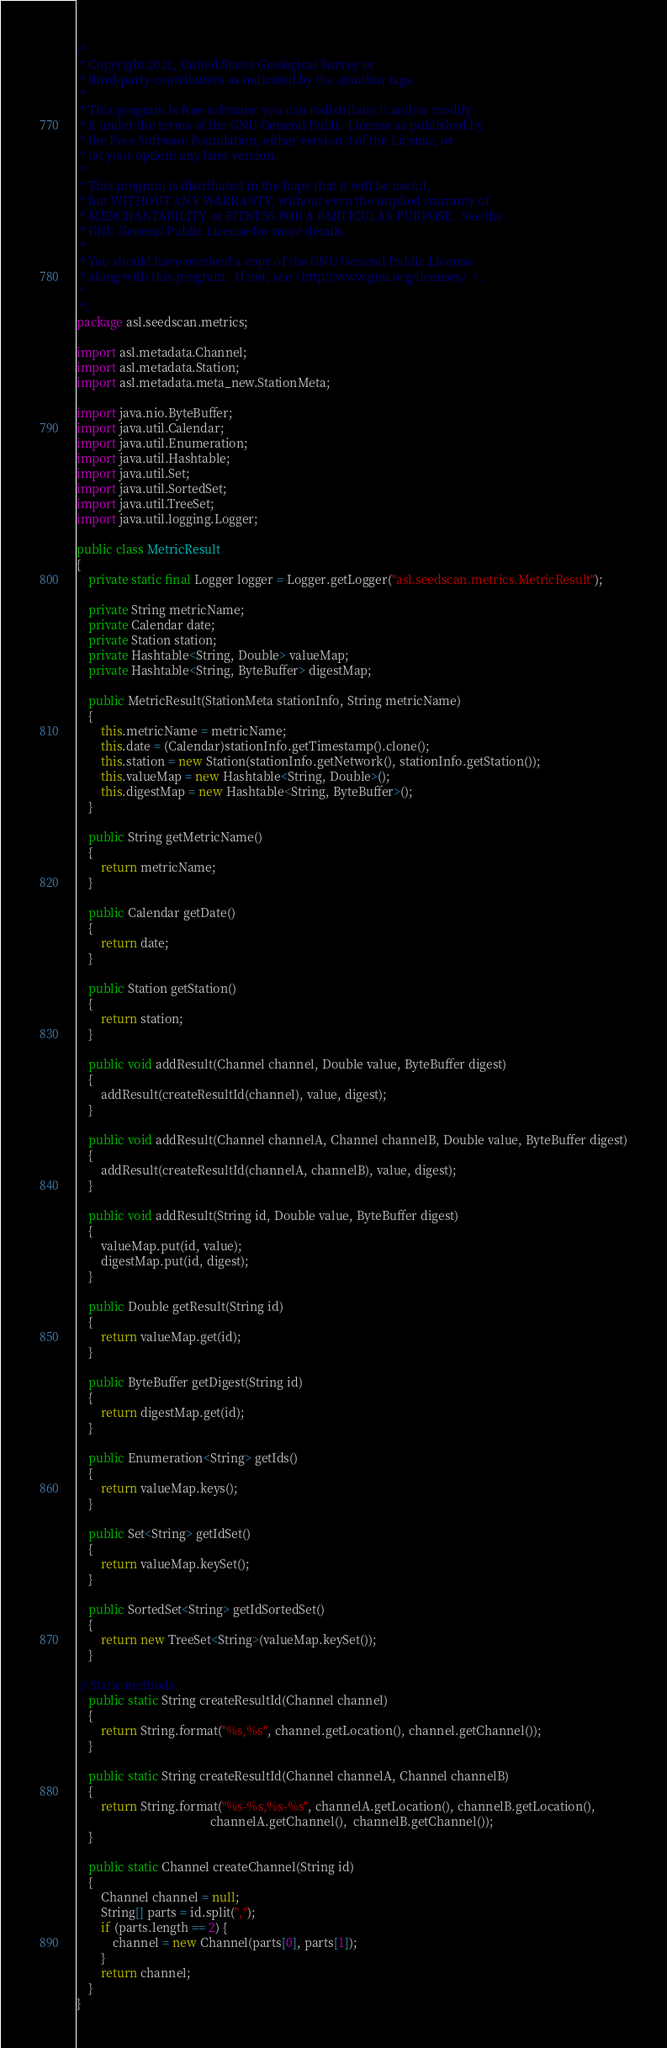<code> <loc_0><loc_0><loc_500><loc_500><_Java_>/*
 * Copyright 2012, United States Geological Survey or
 * third-party contributors as indicated by the @author tags.
 *
 * This program is free software: you can redistribute it and/or modify
 * it under the terms of the GNU General Public License as published by
 * the Free Software Foundation, either version 3 of the License, or
 * (at your option) any later version.
 *
 * This program is distributed in the hope that it will be useful,
 * but WITHOUT ANY WARRANTY; without even the implied warranty of
 * MERCHANTABILITY or FITNESS FOR A PARTICULAR PURPOSE.  See the
 * GNU General Public License for more details.
 *
 * You should have received a copy of the GNU General Public License
 * along with this program.  If not, see <http://www.gnu.org/licenses/  >.
 *
 */
package asl.seedscan.metrics;

import asl.metadata.Channel;
import asl.metadata.Station;
import asl.metadata.meta_new.StationMeta;

import java.nio.ByteBuffer;
import java.util.Calendar;
import java.util.Enumeration;
import java.util.Hashtable;
import java.util.Set;
import java.util.SortedSet;
import java.util.TreeSet;
import java.util.logging.Logger;

public class MetricResult
{
    private static final Logger logger = Logger.getLogger("asl.seedscan.metrics.MetricResult");

    private String metricName;
    private Calendar date;
    private Station station;
    private Hashtable<String, Double> valueMap;
    private Hashtable<String, ByteBuffer> digestMap;

    public MetricResult(StationMeta stationInfo, String metricName)
    {
    	this.metricName = metricName;
    	this.date = (Calendar)stationInfo.getTimestamp().clone();
    	this.station = new Station(stationInfo.getNetwork(), stationInfo.getStation());
        this.valueMap = new Hashtable<String, Double>();
        this.digestMap = new Hashtable<String, ByteBuffer>();
    }
    
    public String getMetricName()
    {
    	return metricName;
    }
    
    public Calendar getDate()
    {
    	return date;
    }
    
    public Station getStation()
    {
    	return station;
    }
    
    public void addResult(Channel channel, Double value, ByteBuffer digest)
    {
        addResult(createResultId(channel), value, digest);
    }
    
    public void addResult(Channel channelA, Channel channelB, Double value, ByteBuffer digest)
    {
        addResult(createResultId(channelA, channelB), value, digest);
    }
    
    public void addResult(String id, Double value, ByteBuffer digest)
    {
        valueMap.put(id, value);
        digestMap.put(id, digest);
    }

    public Double getResult(String id)
    {
        return valueMap.get(id);
    }
    
    public ByteBuffer getDigest(String id)
    {
    	return digestMap.get(id);
    }

    public Enumeration<String> getIds()
    {
        return valueMap.keys();
    }

    public Set<String> getIdSet()
    {
        return valueMap.keySet();
    }

    public SortedSet<String> getIdSortedSet()
    {
        return new TreeSet<String>(valueMap.keySet());
    }

 // Static methods
    public static String createResultId(Channel channel)
    {
    	return String.format("%s,%s", channel.getLocation(), channel.getChannel());
    }
    
    public static String createResultId(Channel channelA, Channel channelB)
    {
    	return String.format("%s-%s,%s-%s", channelA.getLocation(), channelB.getLocation(),
    										channelA.getChannel(),  channelB.getChannel());
    }
    
    public static Channel createChannel(String id)
    {
    	Channel channel = null;
    	String[] parts = id.split(",");
    	if (parts.length == 2) {
    		channel = new Channel(parts[0], parts[1]);
    	}
    	return channel;
    }
}

</code> 